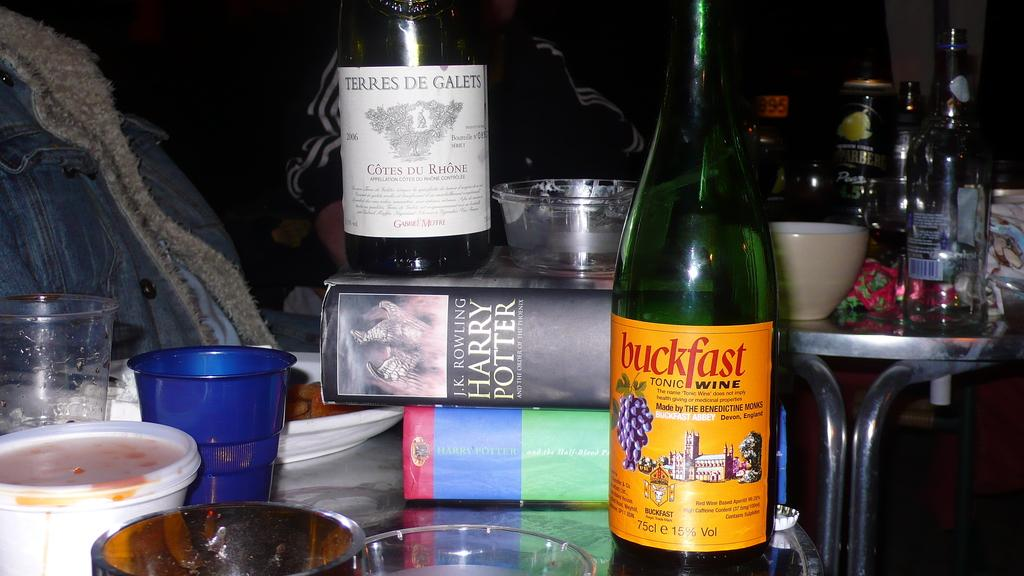What types of containers are visible in the image? There are bottles, boxes, cups, buckets, plates, and bowls in the image. What type of furniture is present in the image? There are tables in the image. What are the people in the image doing? The people are sitting at the table. How many different types of containers can be seen in the image? There are six different types of containers: bottles, boxes, cups, buckets, plates, and bowls. What type of lunch is being served on the plates in the image? There is no indication of any lunch being served in the image; it only shows the containers and people sitting at the table. Who is the guide in the image? There is no guide present in the image. 